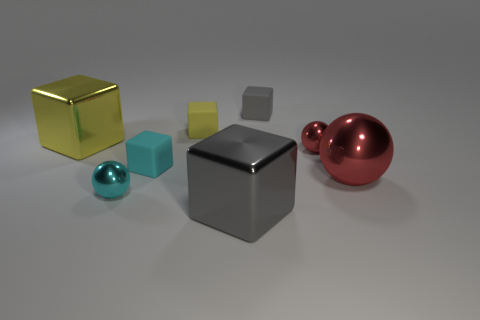Do the large sphere and the tiny metallic sphere to the right of the small cyan shiny ball have the same color?
Offer a very short reply. Yes. There is a yellow matte thing; are there any cubes in front of it?
Your answer should be compact. Yes. Does the metallic cube that is behind the large gray cube have the same size as the gray thing in front of the yellow matte object?
Keep it short and to the point. Yes. Are there any other things of the same size as the yellow metallic thing?
Offer a very short reply. Yes. There is a small metal object to the left of the tiny gray rubber object; does it have the same shape as the gray matte thing?
Ensure brevity in your answer.  No. There is a small cyan object behind the cyan ball; what is it made of?
Your answer should be compact. Rubber. There is a tiny metal object that is to the left of the metal cube in front of the big yellow metal cube; what shape is it?
Offer a terse response. Sphere. There is a large yellow shiny thing; does it have the same shape as the tiny red object behind the tiny cyan metal sphere?
Offer a very short reply. No. There is a tiny ball that is right of the gray shiny block; what number of gray things are in front of it?
Ensure brevity in your answer.  1. There is another yellow object that is the same shape as the yellow matte object; what material is it?
Your response must be concise. Metal. 